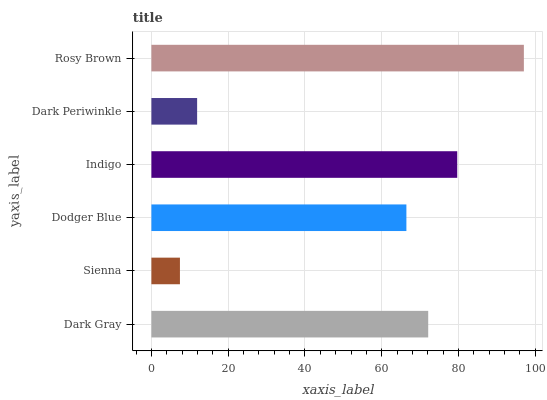Is Sienna the minimum?
Answer yes or no. Yes. Is Rosy Brown the maximum?
Answer yes or no. Yes. Is Dodger Blue the minimum?
Answer yes or no. No. Is Dodger Blue the maximum?
Answer yes or no. No. Is Dodger Blue greater than Sienna?
Answer yes or no. Yes. Is Sienna less than Dodger Blue?
Answer yes or no. Yes. Is Sienna greater than Dodger Blue?
Answer yes or no. No. Is Dodger Blue less than Sienna?
Answer yes or no. No. Is Dark Gray the high median?
Answer yes or no. Yes. Is Dodger Blue the low median?
Answer yes or no. Yes. Is Dodger Blue the high median?
Answer yes or no. No. Is Dark Periwinkle the low median?
Answer yes or no. No. 